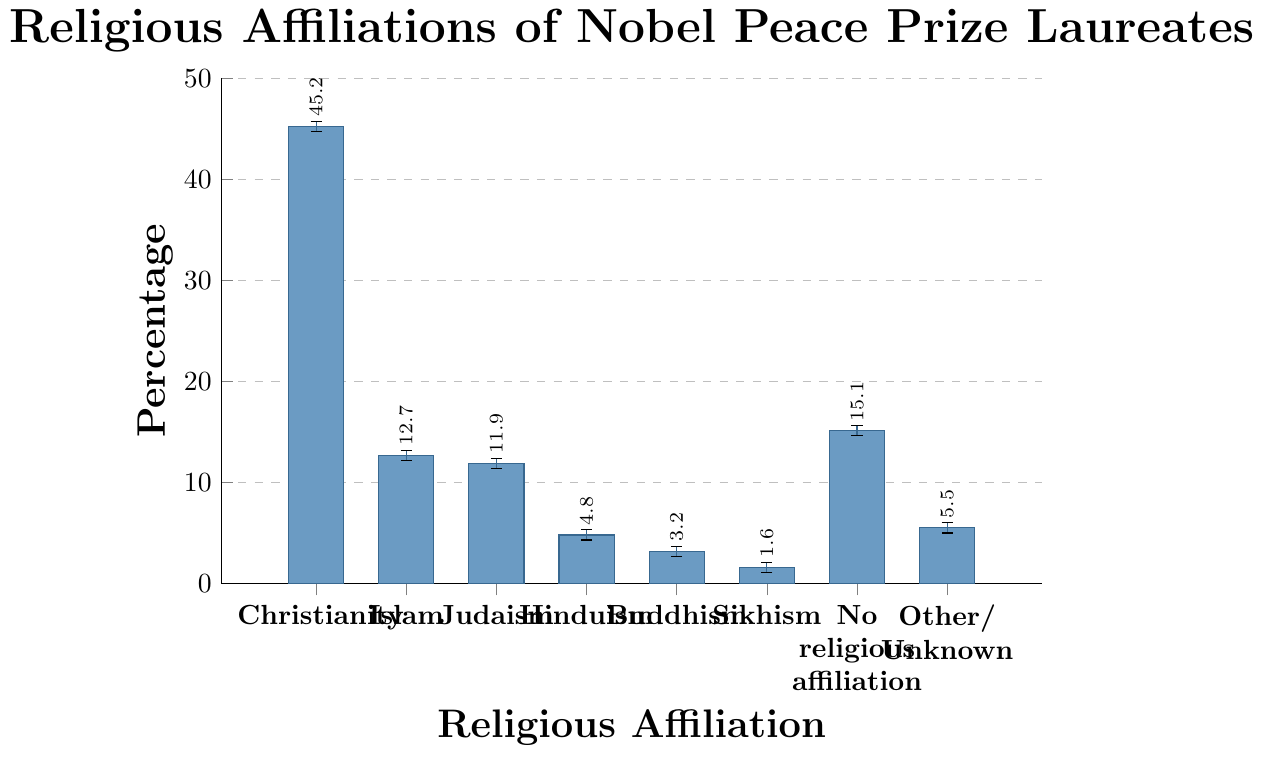Which religious affiliation has the highest percentage of Nobel Peace Prize laureates? Observing the chart, the bar representing Christianity is the tallest, indicating the highest percentage.
Answer: Christianity Which religious affiliation has the lowest percentage of Nobel Peace Prize laureates? The shortest bar in the chart represents Sikhism, indicating the lowest percentage.
Answer: Sikhism How much greater is the percentage of Nobel laureates with Christianity affiliation compared to those with no religious affiliation? The percentage for Christianity is 45.2%, and for no religious affiliation, it is 15.1%. Subtracting these values gives 45.2% - 15.1% = 30.1%.
Answer: 30.1% What is the combined percentage of Nobel Peace Prize laureates associated with Islam and Judaism? The percentage for Islam is 12.7% and for Judaism, it is 11.9%. Adding these values gives 12.7% + 11.9% = 24.6%.
Answer: 24.6% How many religious affiliations have a percentage of Nobel Peace Prize laureates higher than 10%? Observing the chart, Christianity (45.2%), Islam (12.7%), and Judaism (11.9%) have percentages higher than 10%. In total, there are 3 such affiliations.
Answer: 3 Which group has a higher percentage: Buddhism or Hinduism? Comparing the heights of the respective bars, Hinduism (4.8%) is taller than Buddhism (3.2%).
Answer: Hinduism What is the difference between the percentages of Nobel laureates with Sikhism and those with Buddhism affiliations? Sikhism has 1.6% and Buddhism has 3.2%. Subtracting these values gives 3.2% - 1.6% = 1.6%.
Answer: 1.6% If the percentages of laureates with no religious affiliation and those with other/unknown affiliations are combined, what is their total? No religious affiliation is 15.1%, and other/unknown is 5.5%. Adding these values gives 15.1% + 5.5% = 20.6%.
Answer: 20.6% Compare the percentages of Nobel Peace Prize laureates associated with Islam and no religious affiliation. Which one is higher, and by how much? Islam has 12.7% and no religious affiliation has 15.1%. No religious affiliation is higher by 15.1% - 12.7% = 2.4%.
Answer: No religious affiliation, 2.4% What is the average percentage of Nobel laureates associated with Judaism, Hinduism, Buddhism, and Sikhism? Summing these percentages and dividing by the number of groups: (11.9% + 4.8% + 3.2% + 1.6%) / 4 = 21.5% / 4 = 5.375%.
Answer: 5.375% 